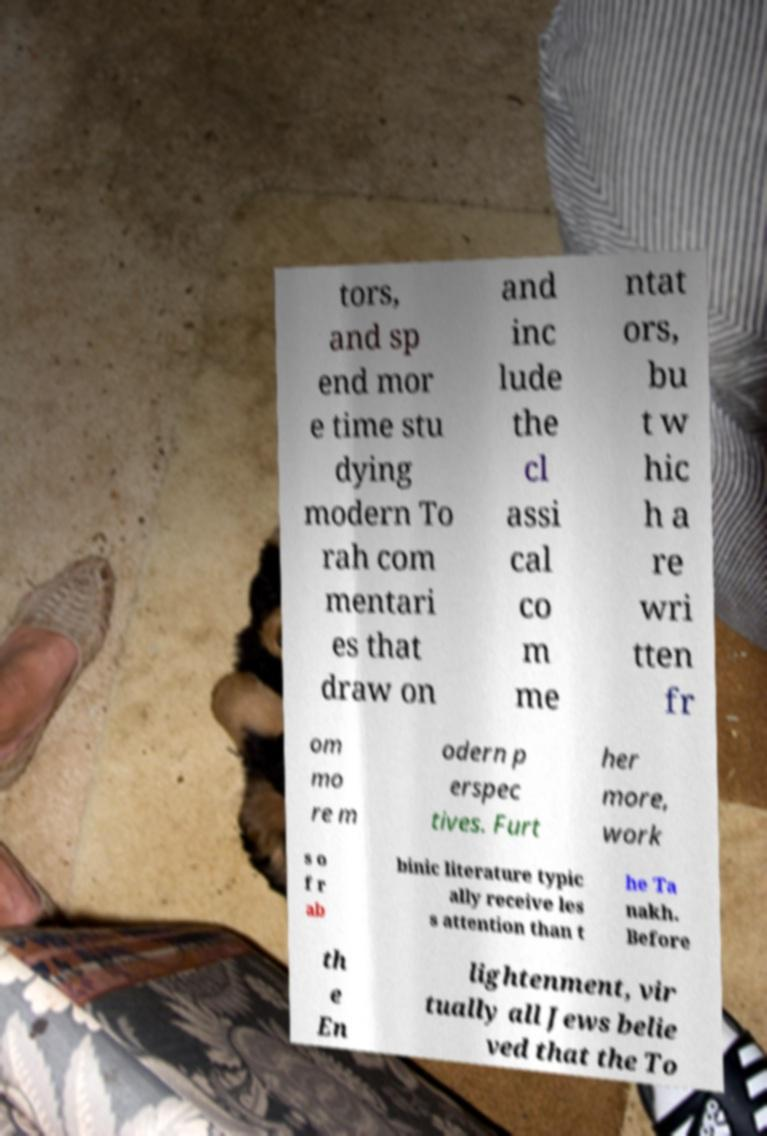Please read and relay the text visible in this image. What does it say? tors, and sp end mor e time stu dying modern To rah com mentari es that draw on and inc lude the cl assi cal co m me ntat ors, bu t w hic h a re wri tten fr om mo re m odern p erspec tives. Furt her more, work s o f r ab binic literature typic ally receive les s attention than t he Ta nakh. Before th e En lightenment, vir tually all Jews belie ved that the To 